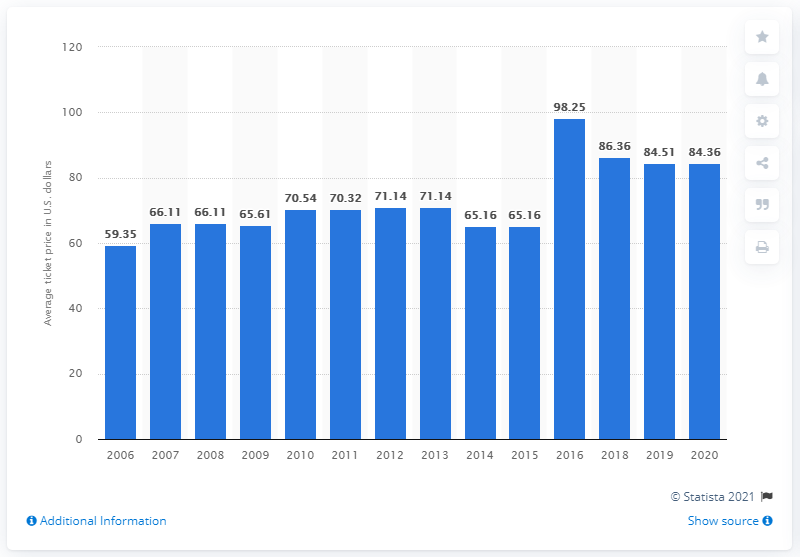Outline some significant characteristics in this image. The average ticket price for Miami Dolphins games in 2020 was $84.36. 